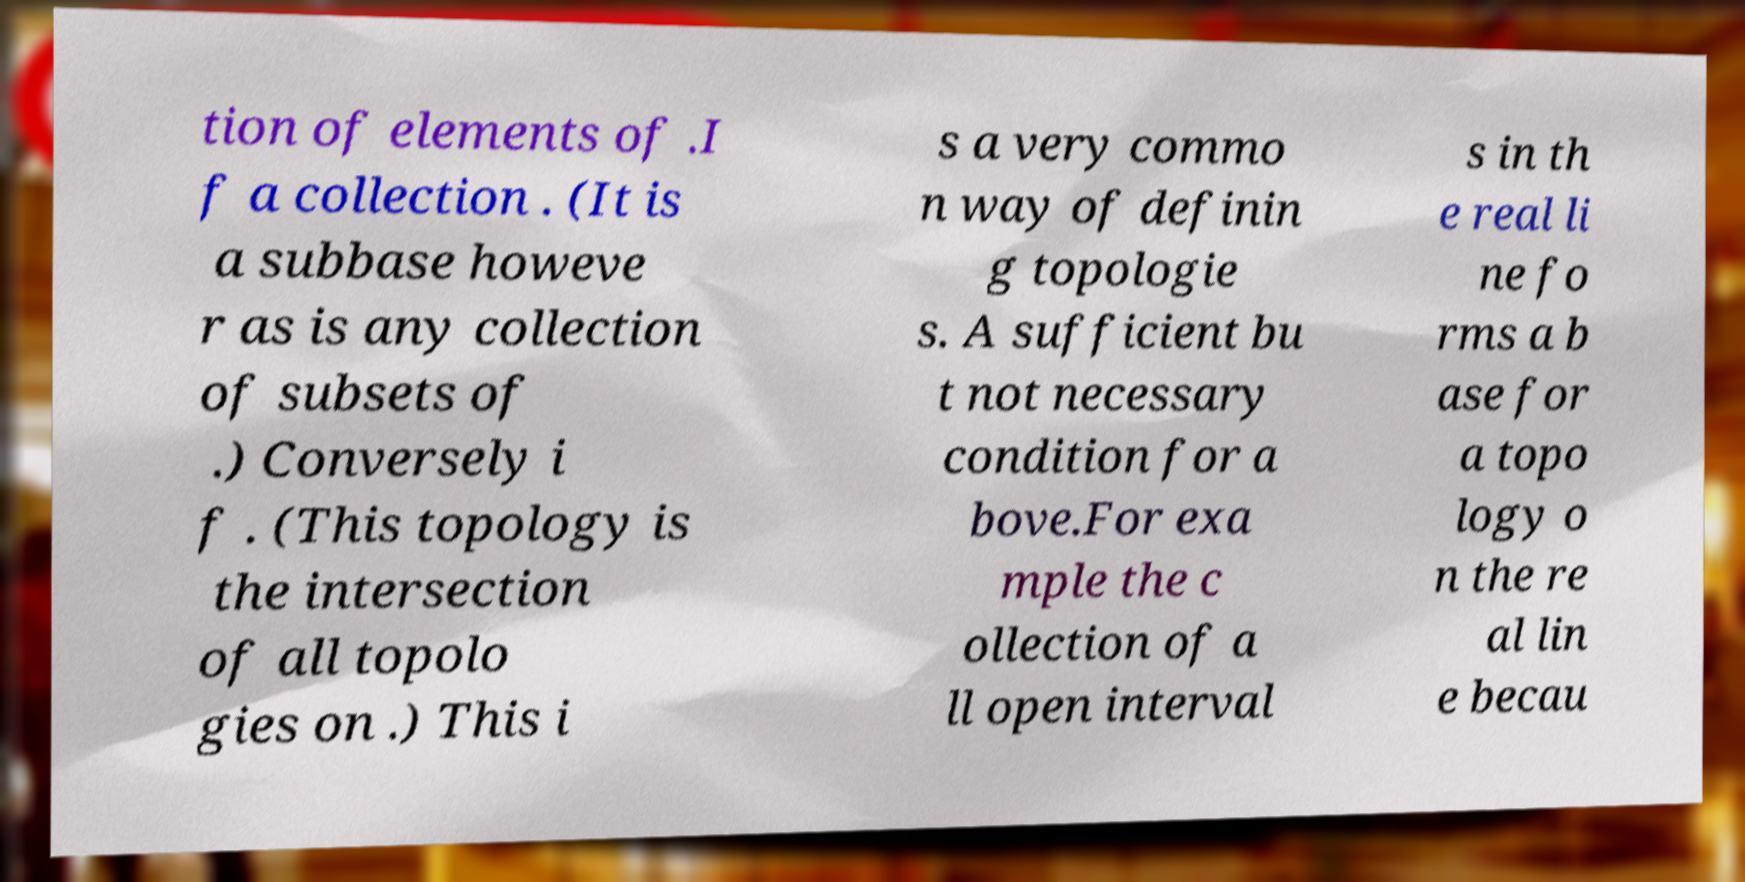Please identify and transcribe the text found in this image. tion of elements of .I f a collection . (It is a subbase howeve r as is any collection of subsets of .) Conversely i f . (This topology is the intersection of all topolo gies on .) This i s a very commo n way of definin g topologie s. A sufficient bu t not necessary condition for a bove.For exa mple the c ollection of a ll open interval s in th e real li ne fo rms a b ase for a topo logy o n the re al lin e becau 